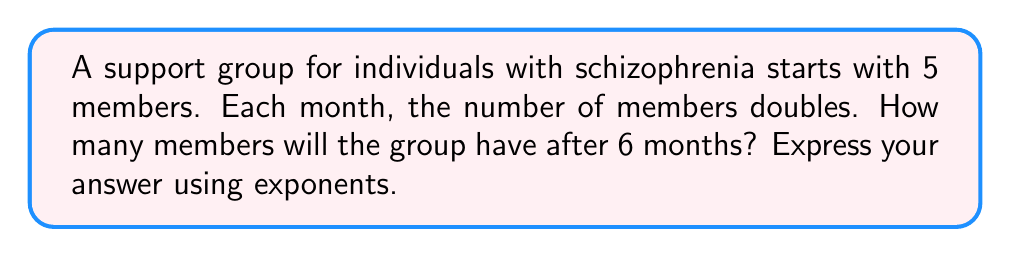Could you help me with this problem? Let's approach this step-by-step:

1) We start with 5 members.

2) Each month, the number doubles. This means we multiply by 2 each month.

3) We need to find the number of members after 6 months, so we'll multiply by 2 six times:

   $5 \times 2 \times 2 \times 2 \times 2 \times 2 \times 2$

4) This can be written as an exponent:

   $5 \times 2^6$

5) To calculate $2^6$:
   
   $2^6 = 2 \times 2 \times 2 \times 2 \times 2 \times 2 = 64$

6) Therefore, the final calculation is:

   $5 \times 2^6 = 5 \times 64 = 320$

So, after 6 months, there will be 320 members in the support group.
Answer: $5 \times 2^6$ or 320 